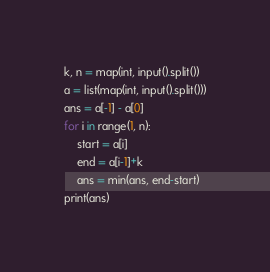Convert code to text. <code><loc_0><loc_0><loc_500><loc_500><_Python_>k, n = map(int, input().split())
a = list(map(int, input().split()))
ans = a[-1] - a[0]
for i in range(1, n):
    start = a[i]
    end = a[i-1]+k
    ans = min(ans, end-start)
print(ans)</code> 